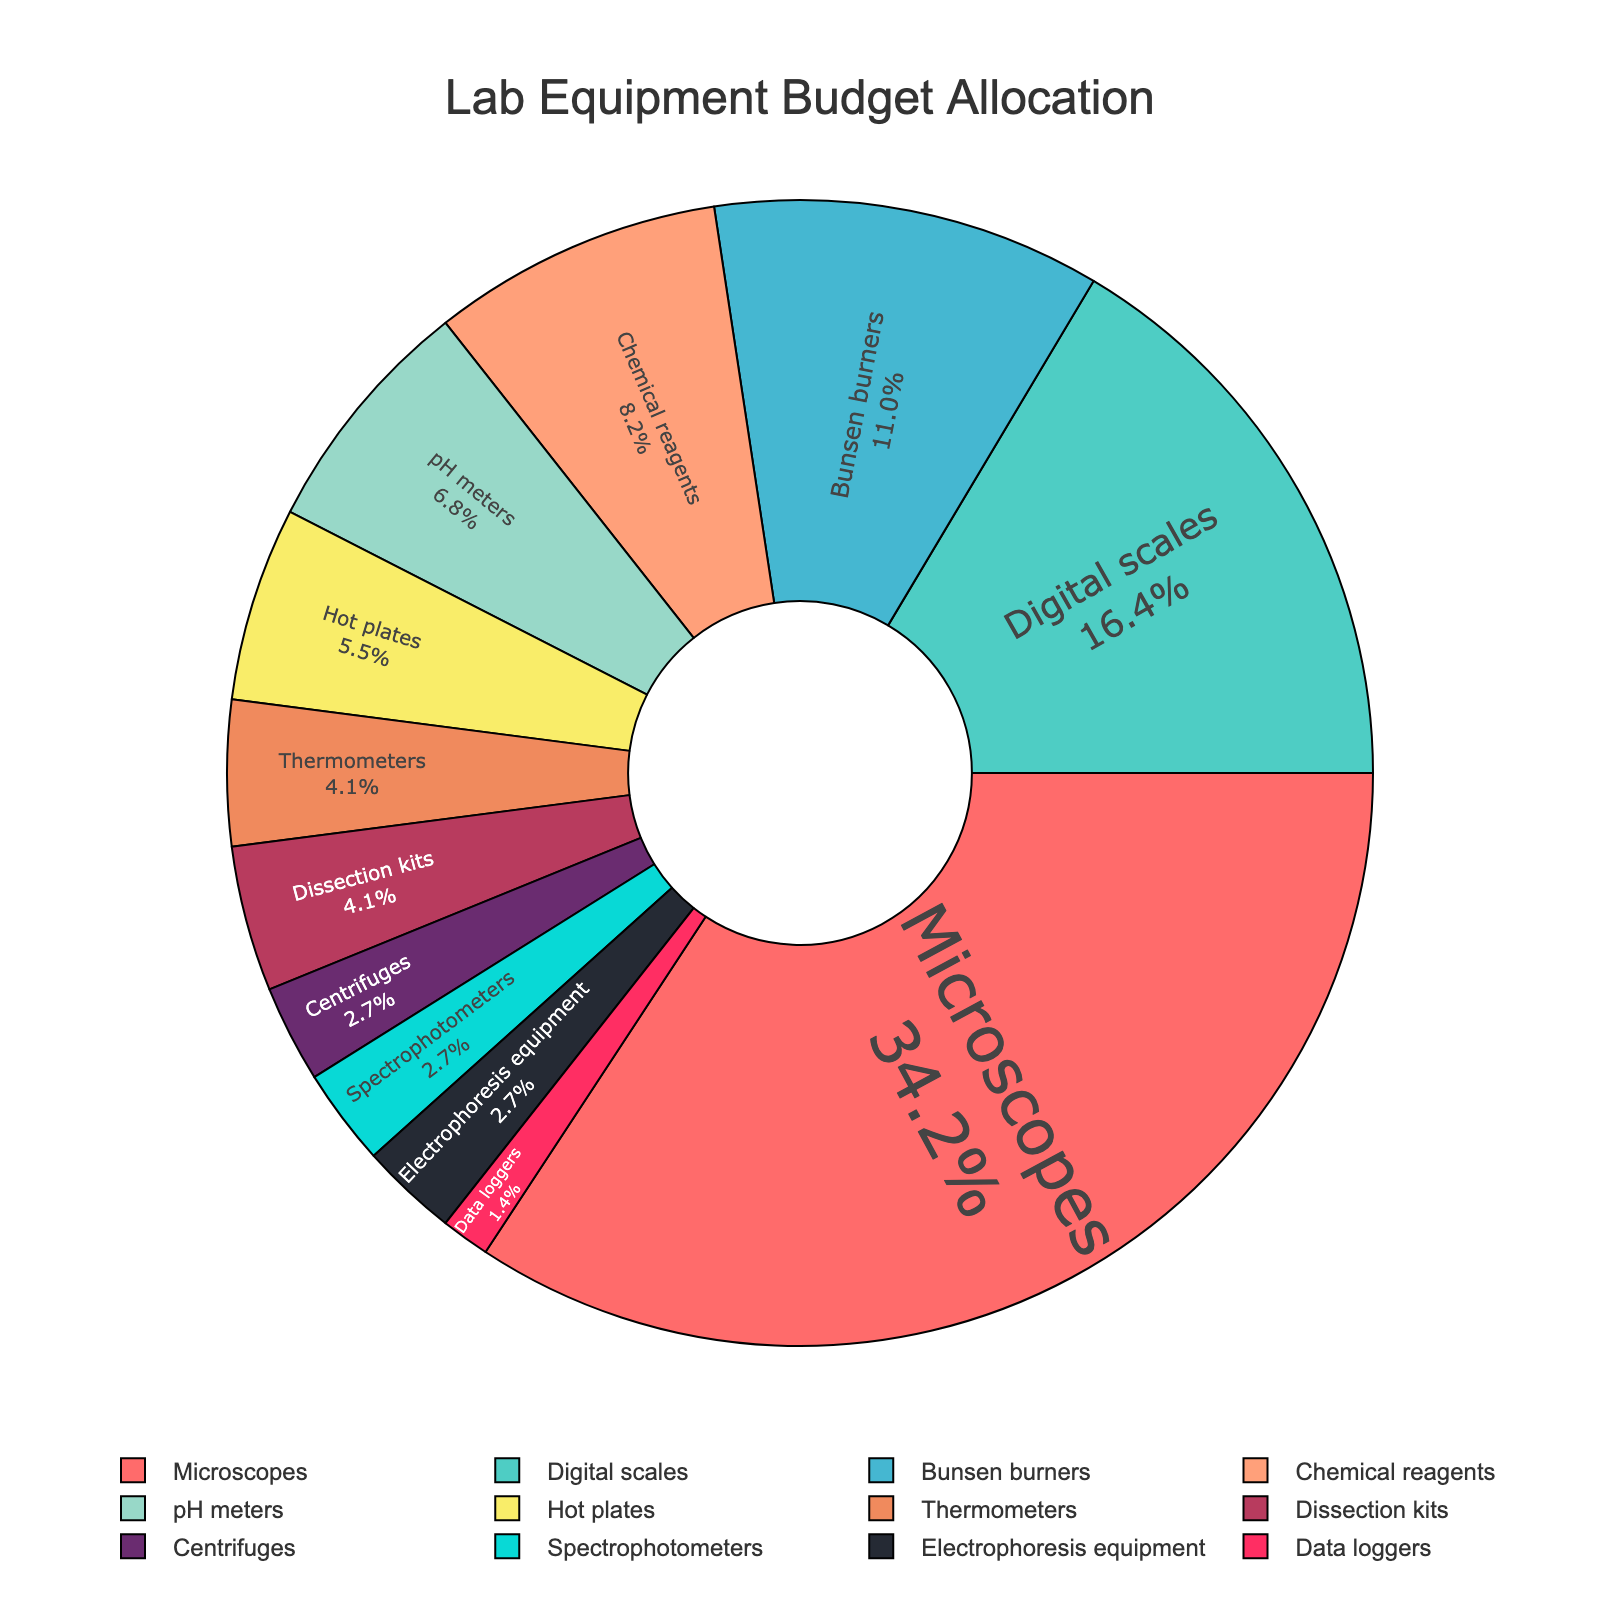Which equipment category received the highest percentage of the budget allocation? The slice representing "Microscopes" is the largest in the pie chart, and it states 25%. Therefore, "Microscopes" received the highest percentage of the budget allocation.
Answer: Microscopes What is the combined budget percentage for "Bunsen burners" and "Chemical reagents"? "Bunsen burners" got 8%, and "Chemical reagents" got 6%. Adding these together gives you 8% + 6% = 14%.
Answer: 14% How does the budget allocation for "Digital scales" compare to "Bunsen burners"? "Digital scales" have a budget allocation of 12% while "Bunsen burners" have 8%. Since 12% is greater than 8%, "Digital scales" have a larger budget allocation compared to "Bunsen burners".
Answer: Digital scales have a larger allocation Which two equipment categories share the same budget allocation and what is it? Both "Centrifuges" and "Spectrophotometers" have the same budget allocation, each at 2%.
Answer: Centrifuges and Spectrophotometers, 2% What is the color of the pie slice representing "Hot plates"? The pie slice for "Hot plates" is labeled as 4% and is colored light yellow. Based on the color, it is likely represented by a light yellow (close to "#F9ED69").
Answer: Light Yellow What is the sum of the budget percentages for equipment categories with less than 5% allocation? The equipment categories with less than 5% allocation are "pH meters" (5%), "Hot plates" (4%), "Thermometers" (3%), "Dissection kits" (3%), "Centrifuges" (2%), "Spectrophotometers" (2%), "Electrophoresis equipment" (2%), and "Data loggers" (1%). Adding these gives 5% + 4% + 3% + 3% + 2% + 2% + 2% + 1% = 22%.
Answer: 22% What is the difference in budget allocation between the largest and smallest slice in the pie chart? The largest slice is "Microscopes" with 25%, and the smallest slice is "Data loggers" with 1%. The difference is calculated as 25% - 1% = 24%.
Answer: 24% What percentage of the budget is allocated to equipment with at least 10% of the budget? The equipment with at least 10% allocation are "Microscopes" (25%) and "Digital scales" (12%). Adding these gives 25% + 12% = 37%.
Answer: 37% 